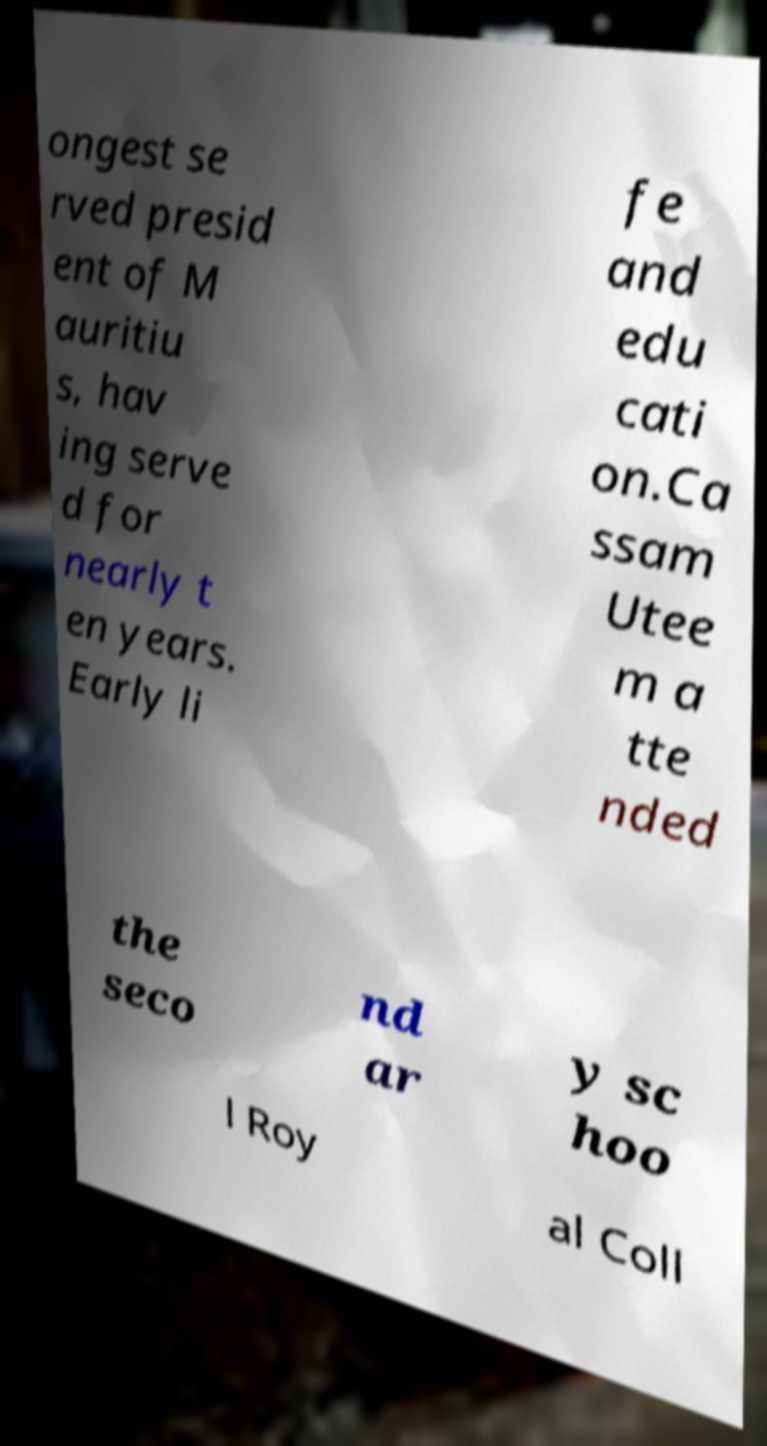For documentation purposes, I need the text within this image transcribed. Could you provide that? ongest se rved presid ent of M auritiu s, hav ing serve d for nearly t en years. Early li fe and edu cati on.Ca ssam Utee m a tte nded the seco nd ar y sc hoo l Roy al Coll 